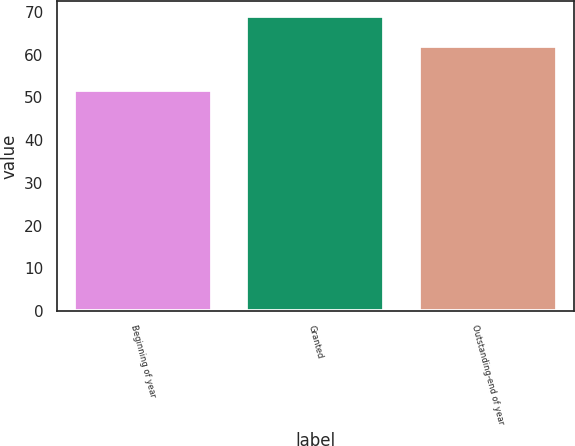<chart> <loc_0><loc_0><loc_500><loc_500><bar_chart><fcel>Beginning of year<fcel>Granted<fcel>Outstanding-end of year<nl><fcel>51.73<fcel>69.04<fcel>61.94<nl></chart> 